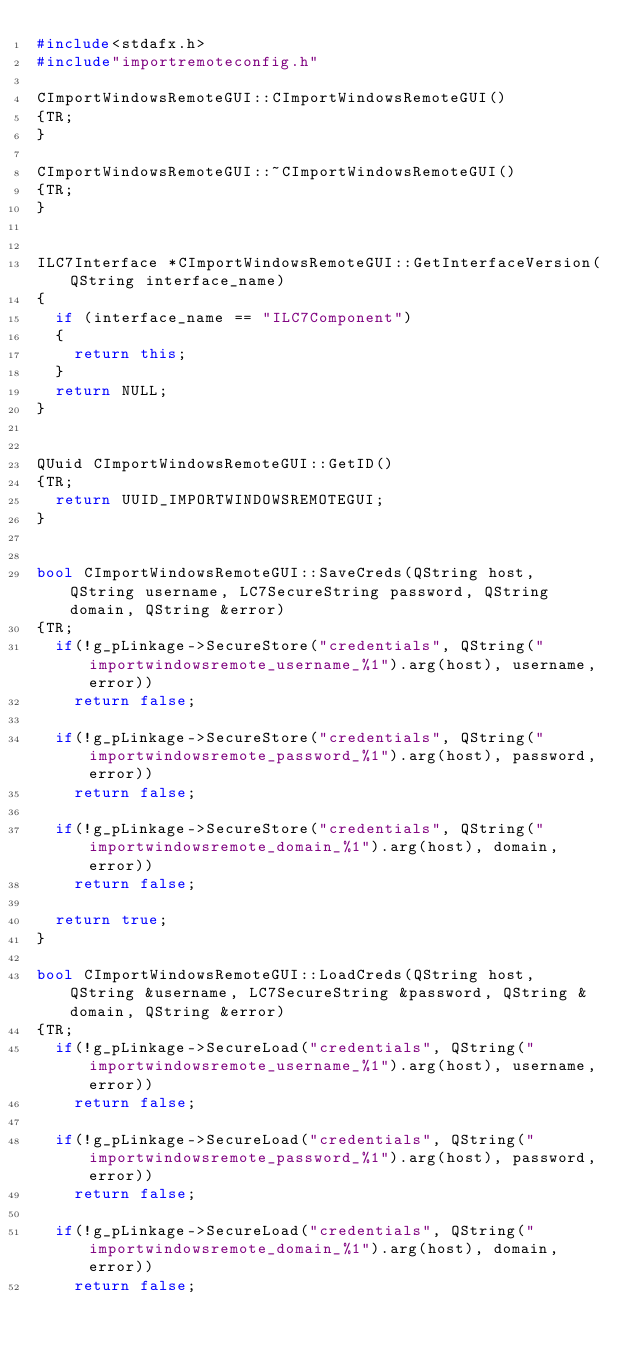Convert code to text. <code><loc_0><loc_0><loc_500><loc_500><_C++_>#include<stdafx.h>
#include"importremoteconfig.h"

CImportWindowsRemoteGUI::CImportWindowsRemoteGUI()
{TR;
}

CImportWindowsRemoteGUI::~CImportWindowsRemoteGUI()
{TR;
}


ILC7Interface *CImportWindowsRemoteGUI::GetInterfaceVersion(QString interface_name)
{
	if (interface_name == "ILC7Component")
	{
		return this;
	}
	return NULL;
}


QUuid CImportWindowsRemoteGUI::GetID()
{TR;
	return UUID_IMPORTWINDOWSREMOTEGUI;
}


bool CImportWindowsRemoteGUI::SaveCreds(QString host, QString username, LC7SecureString password, QString domain, QString &error)
{TR;
	if(!g_pLinkage->SecureStore("credentials", QString("importwindowsremote_username_%1").arg(host), username, error))
		return false;
	
	if(!g_pLinkage->SecureStore("credentials", QString("importwindowsremote_password_%1").arg(host), password, error))
		return false;
	
	if(!g_pLinkage->SecureStore("credentials", QString("importwindowsremote_domain_%1").arg(host), domain, error))
		return false;

	return true;
}

bool CImportWindowsRemoteGUI::LoadCreds(QString host, QString &username, LC7SecureString &password, QString &domain, QString &error)
{TR;
	if(!g_pLinkage->SecureLoad("credentials", QString("importwindowsremote_username_%1").arg(host), username, error))
		return false;
	
	if(!g_pLinkage->SecureLoad("credentials", QString("importwindowsremote_password_%1").arg(host), password, error))
		return false;
	
	if(!g_pLinkage->SecureLoad("credentials", QString("importwindowsremote_domain_%1").arg(host), domain, error))
		return false;
</code> 